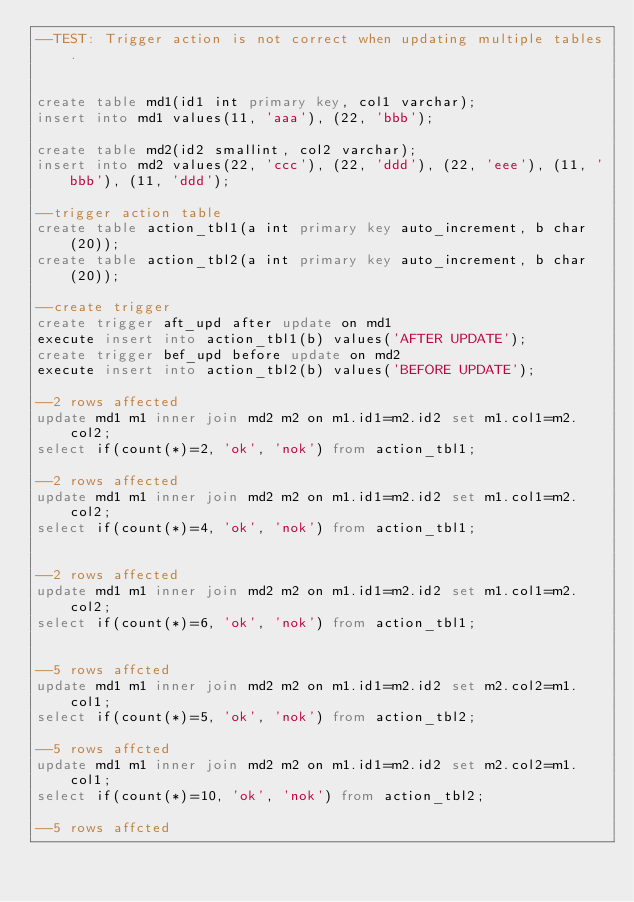Convert code to text. <code><loc_0><loc_0><loc_500><loc_500><_SQL_>--TEST: Trigger action is not correct when updating multiple tables.


create table md1(id1 int primary key, col1 varchar);
insert into md1 values(11, 'aaa'), (22, 'bbb');

create table md2(id2 smallint, col2 varchar);
insert into md2 values(22, 'ccc'), (22, 'ddd'), (22, 'eee'), (11, 'bbb'), (11, 'ddd');

--trigger action table
create table action_tbl1(a int primary key auto_increment, b char(20));
create table action_tbl2(a int primary key auto_increment, b char(20));

--create trigger
create trigger aft_upd after update on md1
execute insert into action_tbl1(b) values('AFTER UPDATE');
create trigger bef_upd before update on md2
execute insert into action_tbl2(b) values('BEFORE UPDATE');

--2 rows affected
update md1 m1 inner join md2 m2 on m1.id1=m2.id2 set m1.col1=m2.col2;
select if(count(*)=2, 'ok', 'nok') from action_tbl1;

--2 rows affected
update md1 m1 inner join md2 m2 on m1.id1=m2.id2 set m1.col1=m2.col2;
select if(count(*)=4, 'ok', 'nok') from action_tbl1;


--2 rows affected
update md1 m1 inner join md2 m2 on m1.id1=m2.id2 set m1.col1=m2.col2;
select if(count(*)=6, 'ok', 'nok') from action_tbl1;


--5 rows affcted
update md1 m1 inner join md2 m2 on m1.id1=m2.id2 set m2.col2=m1.col1;
select if(count(*)=5, 'ok', 'nok') from action_tbl2;

--5 rows affcted
update md1 m1 inner join md2 m2 on m1.id1=m2.id2 set m2.col2=m1.col1;
select if(count(*)=10, 'ok', 'nok') from action_tbl2;
         
--5 rows affcted</code> 